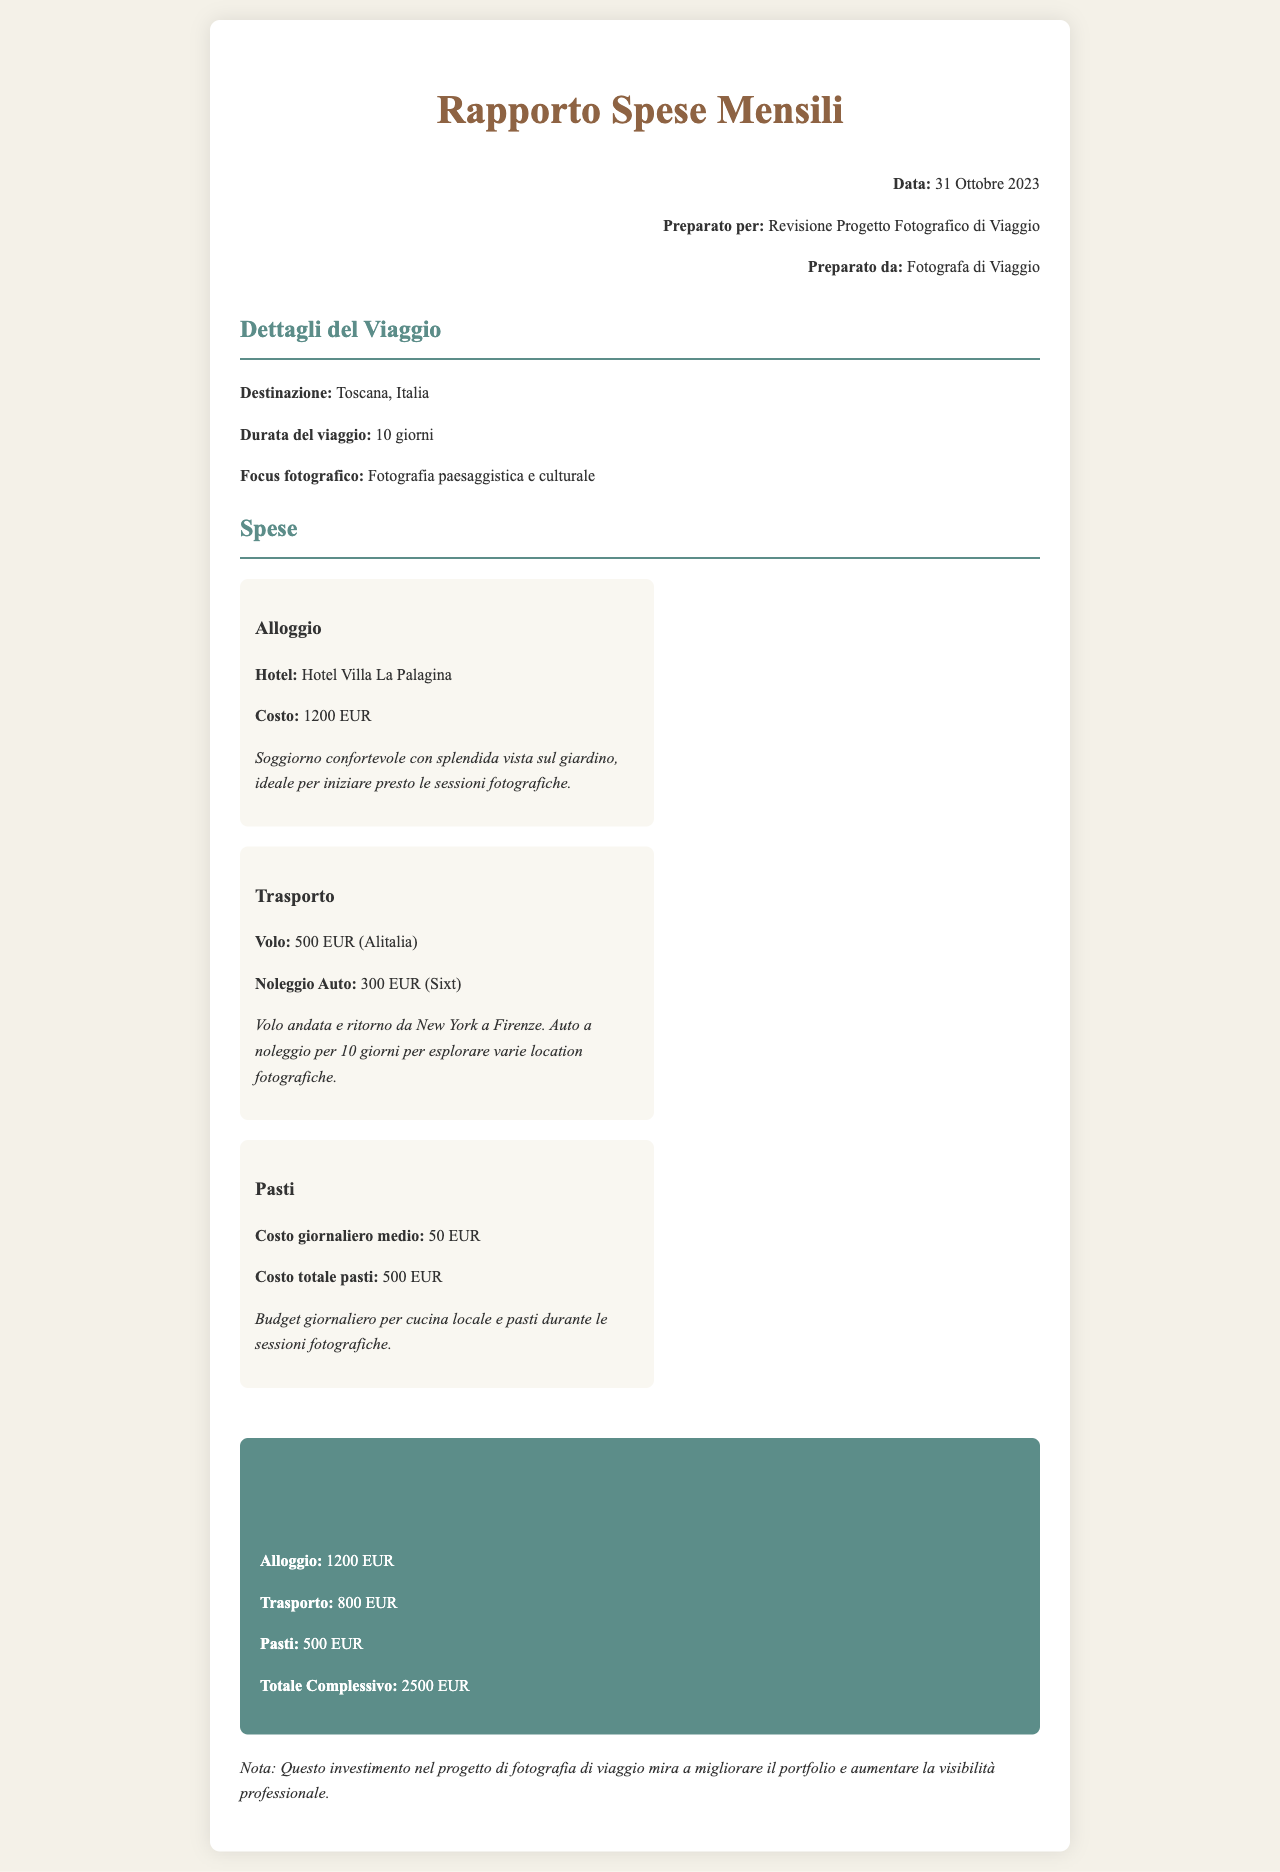Che cos'è il focus fotografico del viaggio? Il focus fotografico del viaggio è specificato nel documento come "Fotografia paesaggistica e culturale".
Answer: Fotografia paesaggistica e culturale Qual è il costo dell'alloggio? Il costo dell'alloggio per il soggiorno è menzionato come 1200 EUR.
Answer: 1200 EUR Qual è la durata del viaggio? La durata del viaggio è indicata come 10 giorni.
Answer: 10 giorni Qual è il costo totale per i pasti? Il costo totale per i pasti è specificato nel documento come 500 EUR.
Answer: 500 EUR Qual è la somma totale delle spese? La somma totale delle spese si calcola sommando le spese per alloggio, trasporto e pasti, risultando in 2500 EUR.
Answer: 2500 EUR Da quale città parte il volo? Il volo di andata e ritorno è da New York a Firenze.
Answer: New York Quale auto è stata noleggiata? L'auto noleggiata è specificata come “Sixt”.
Answer: Sixt Che tipo di hotel è stato scelto? L'hotel scelto è specificato come “Hotel Villa La Palagina”.
Answer: Hotel Villa La Palagina Qual è il costo medio giornaliero dei pasti? Il costo medio giornaliero per i pasti è indicato come 50 EUR.
Answer: 50 EUR 